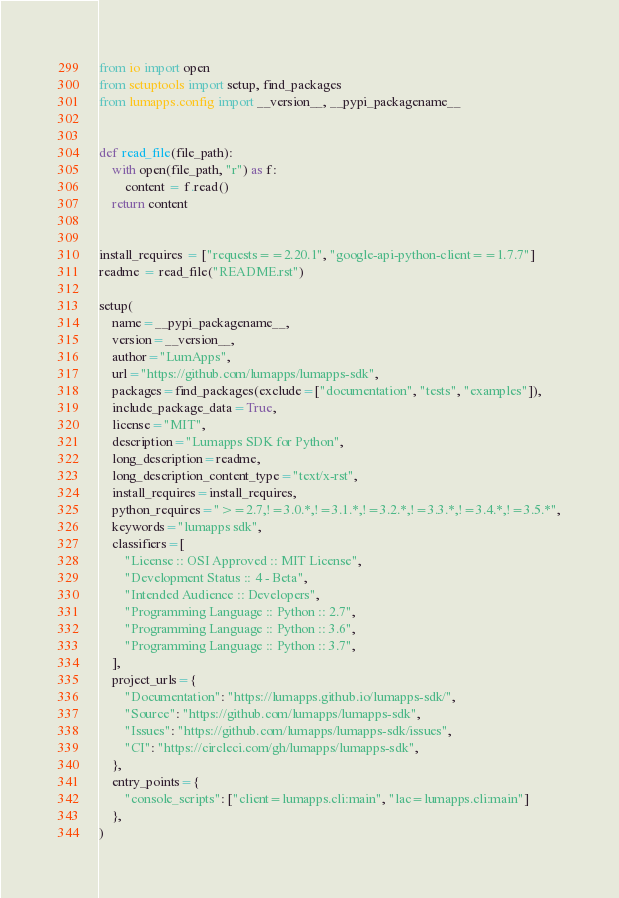Convert code to text. <code><loc_0><loc_0><loc_500><loc_500><_Python_>from io import open
from setuptools import setup, find_packages
from lumapps.config import __version__, __pypi_packagename__


def read_file(file_path):
    with open(file_path, "r") as f:
        content = f.read()
    return content


install_requires = ["requests==2.20.1", "google-api-python-client==1.7.7"]
readme = read_file("README.rst")

setup(
    name=__pypi_packagename__,
    version=__version__,
    author="LumApps",
    url="https://github.com/lumapps/lumapps-sdk",
    packages=find_packages(exclude=["documentation", "tests", "examples"]),
    include_package_data=True,
    license="MIT",
    description="Lumapps SDK for Python",
    long_description=readme,
    long_description_content_type="text/x-rst",
    install_requires=install_requires,
    python_requires=">=2.7,!=3.0.*,!=3.1.*,!=3.2.*,!=3.3.*,!=3.4.*,!=3.5.*",
    keywords="lumapps sdk",
    classifiers=[
        "License :: OSI Approved :: MIT License",
        "Development Status :: 4 - Beta",
        "Intended Audience :: Developers",
        "Programming Language :: Python :: 2.7",
        "Programming Language :: Python :: 3.6",
        "Programming Language :: Python :: 3.7",
    ],
    project_urls={
        "Documentation": "https://lumapps.github.io/lumapps-sdk/",
        "Source": "https://github.com/lumapps/lumapps-sdk",
        "Issues": "https://github.com/lumapps/lumapps-sdk/issues",
        "CI": "https://circleci.com/gh/lumapps/lumapps-sdk",
    },
    entry_points={
        "console_scripts": ["client=lumapps.cli:main", "lac=lumapps.cli:main"]
    },
)
</code> 